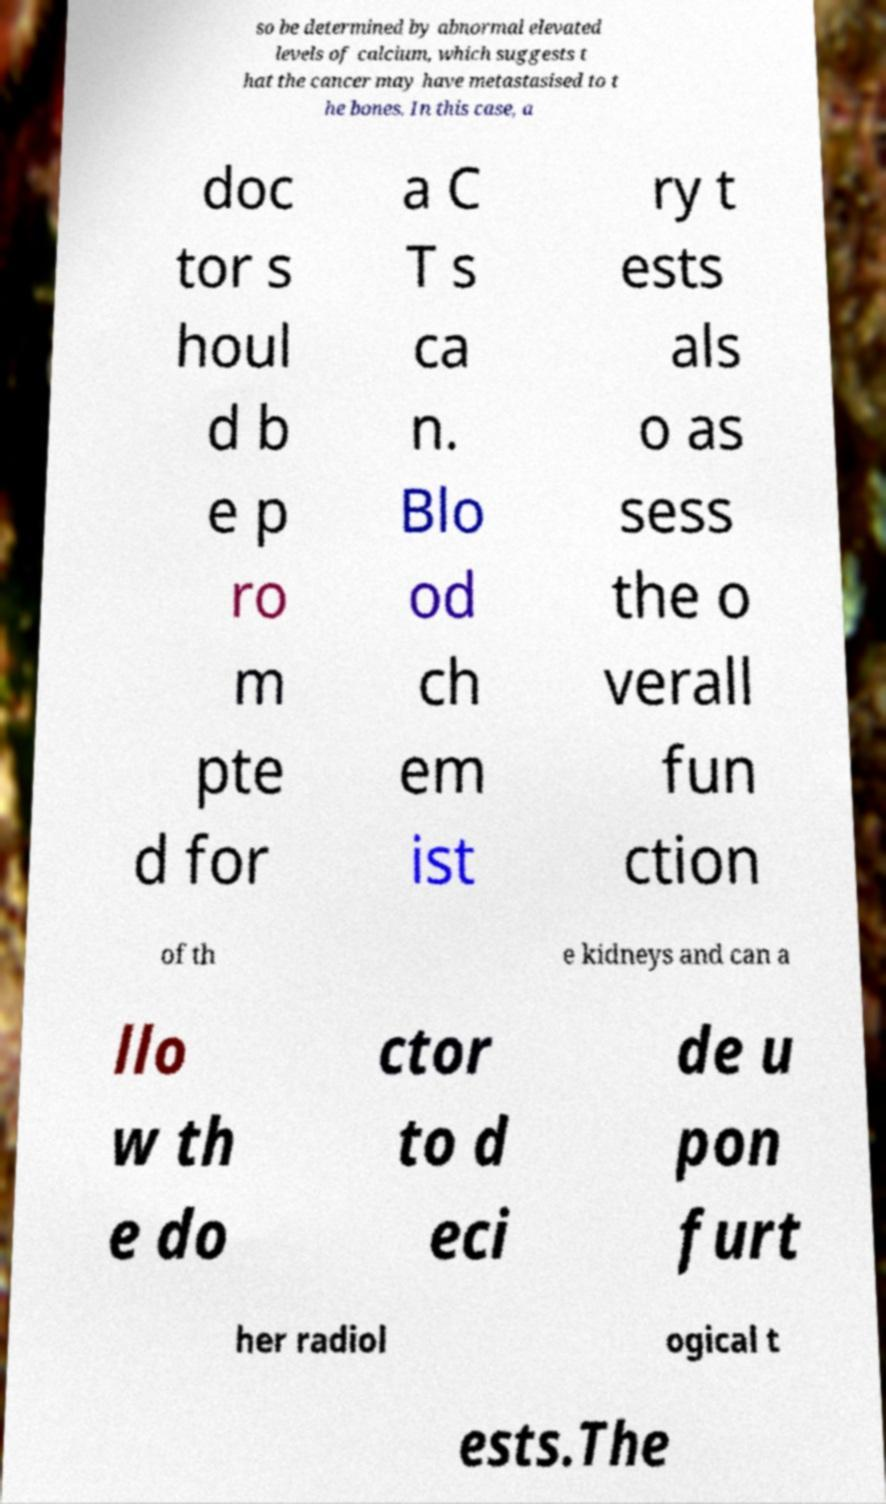Please identify and transcribe the text found in this image. so be determined by abnormal elevated levels of calcium, which suggests t hat the cancer may have metastasised to t he bones. In this case, a doc tor s houl d b e p ro m pte d for a C T s ca n. Blo od ch em ist ry t ests als o as sess the o verall fun ction of th e kidneys and can a llo w th e do ctor to d eci de u pon furt her radiol ogical t ests.The 